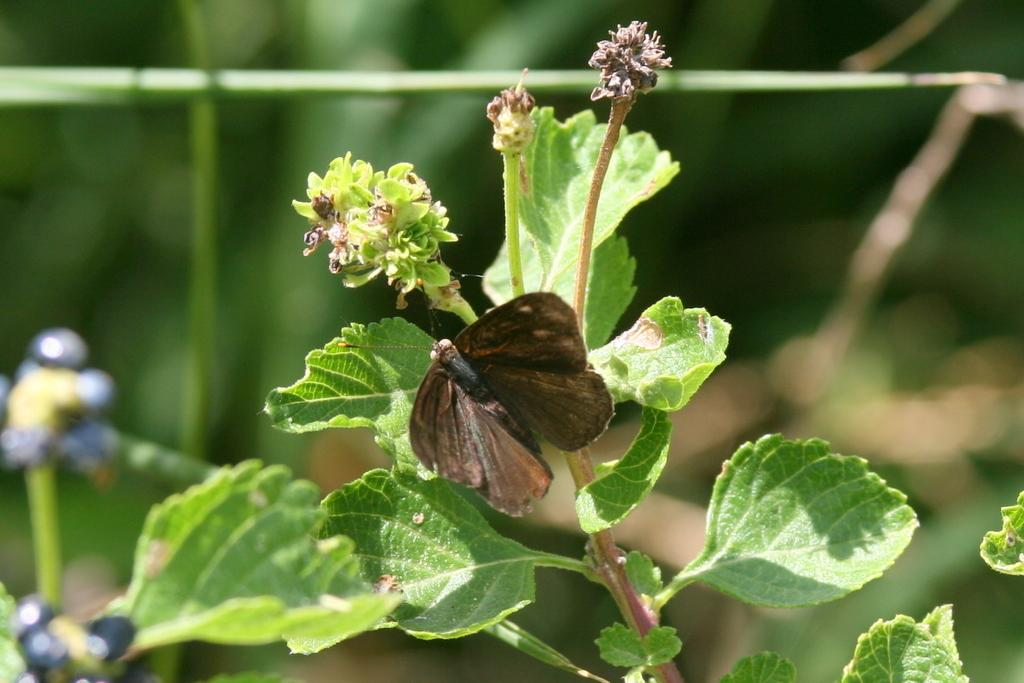What is on the plant in the image? There is a butterfly on a plant in the image. What other floral elements can be seen in the image? There are flowers and buds in the image. How would you describe the background of the image? The background of the image is blurry. What type of banana is being held by the duck in the image? There is no banana or duck present in the image; it features a butterfly on a plant with flowers and buds in the background. 